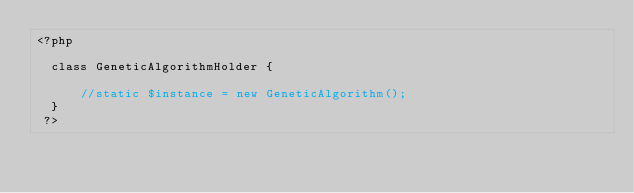Convert code to text. <code><loc_0><loc_0><loc_500><loc_500><_PHP_><?php 

	class GeneticAlgorithmHolder {
	    
	    //static $instance = new GeneticAlgorithm();
	}
 ?></code> 